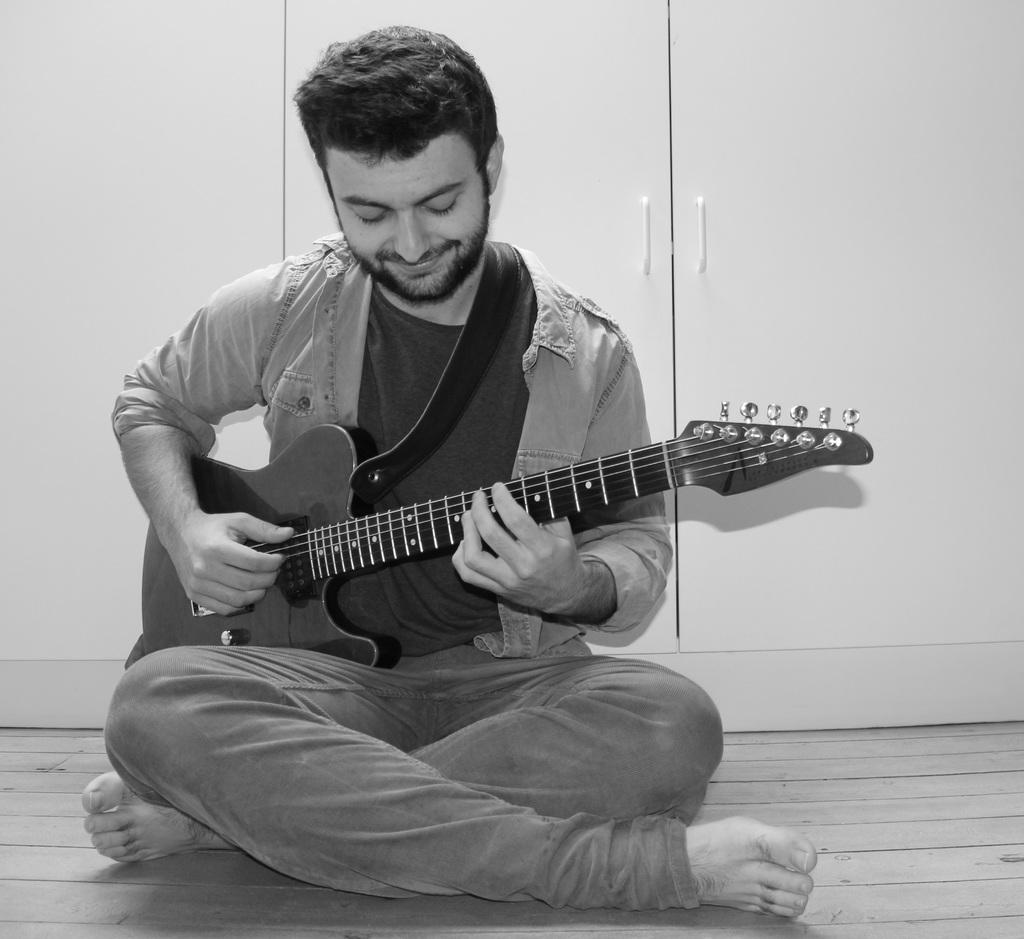What is the main subject of the image? The main subject of the image is a man. What is the man doing in the image? The man is sitting and holding a guitar in his hand. What is the man's facial expression in the image? The man is smiling in the image. What can be seen in the background of the image? There is a door in the background of the image. What is the color scheme of the image? The image is in black and white color. What type of disgust can be seen on the man's face in the image? There is no disgust visible on the man's face in the image; he is smiling. What type of volleyball game is being played in the background of the image? There is no volleyball game present in the image; it only features a man sitting with a guitar and a door in the background. 